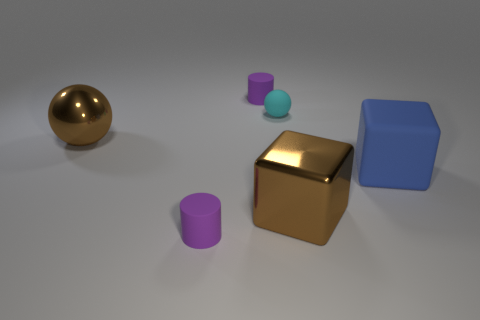What number of other objects are there of the same shape as the blue rubber object? 1 